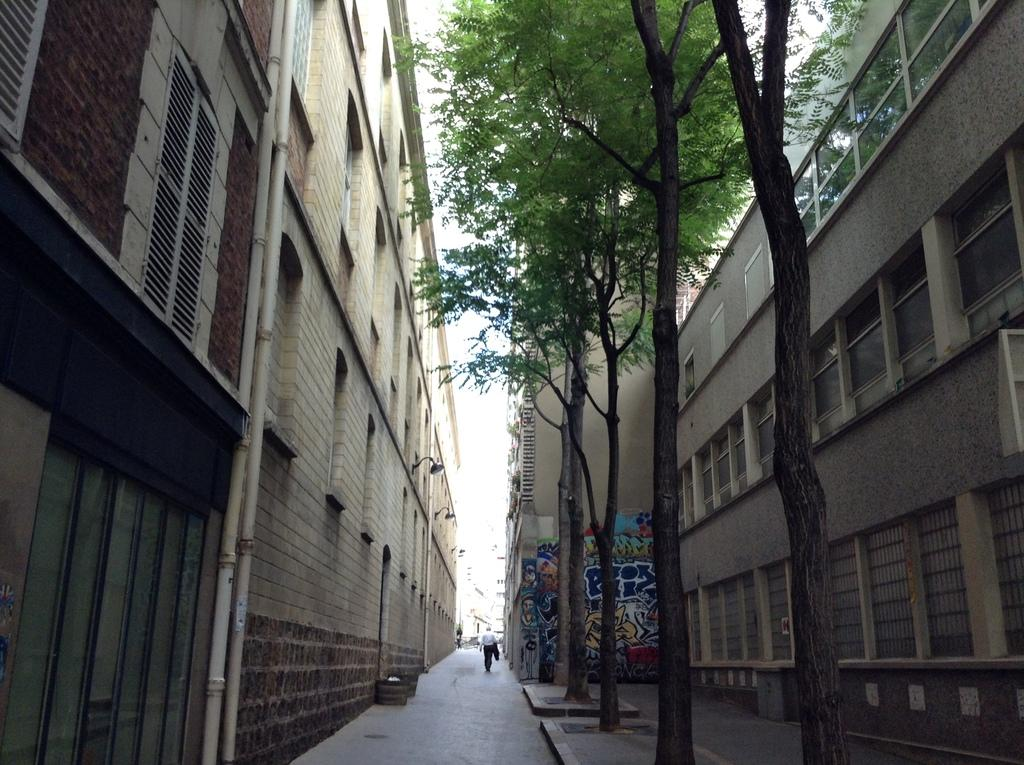What type of structures can be seen in the image? There are buildings in the image. What other natural elements are present in the image? There are trees in the image. Can you describe any artwork visible in the image? There is a painting on a wall in the image. What is the person in the image doing? A person is walking on a pathway in the image. What type of iron is being used by the person in the image? There is no iron present in the image; the person is walking on a pathway. How much weight is the person carrying in the image? The image does not provide information about the person's weight or any items they might be carrying. 